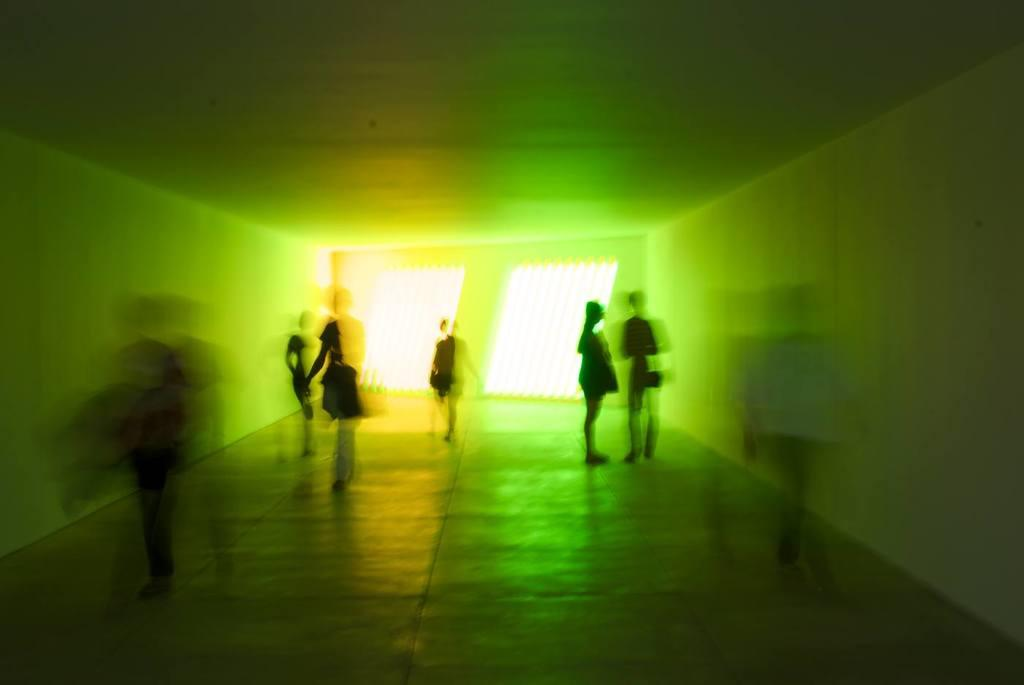What type of structures can be seen in the image? There are walls visible in the image. Are there any living beings present in the image? Yes, there are people in the image. What else can be seen in the image besides the walls and people? There are objects in the image. What type of drug is being written about on the grape in the image? There is no grape or writing about drugs present in the image. 